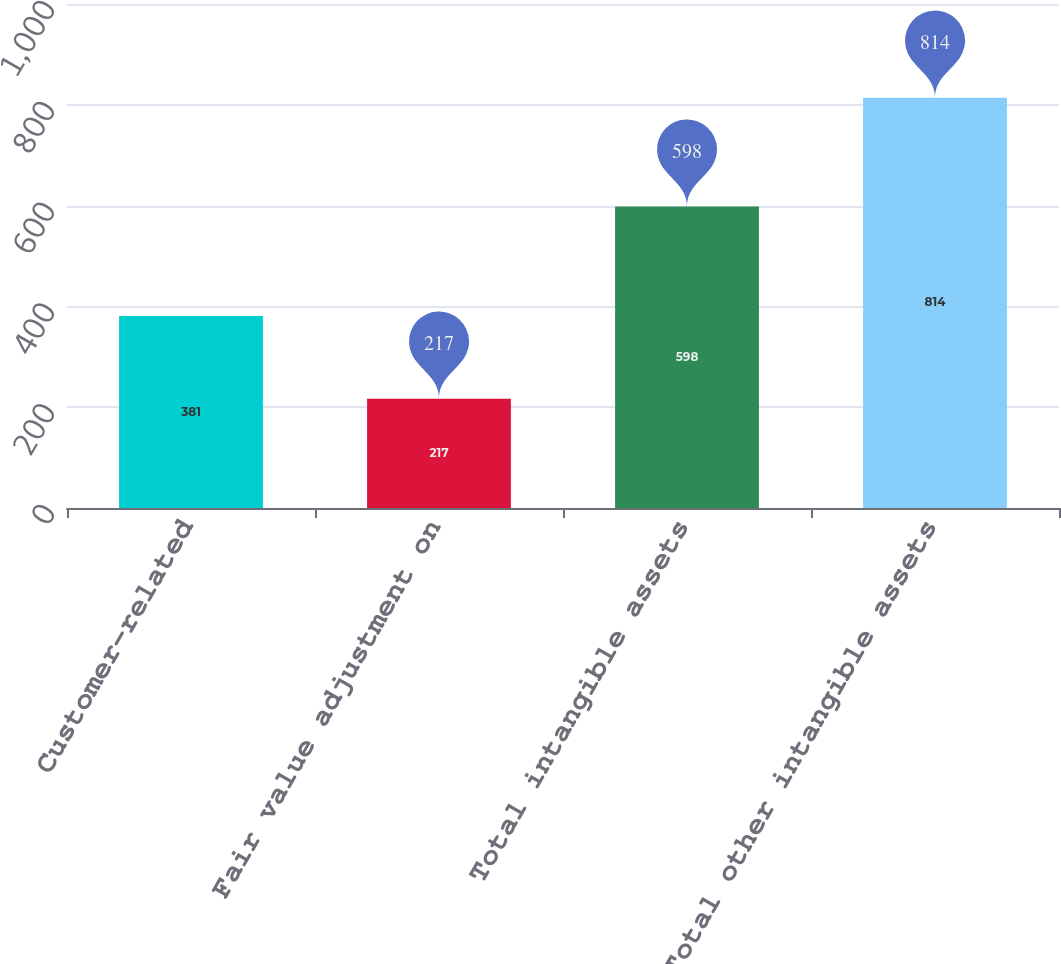Convert chart. <chart><loc_0><loc_0><loc_500><loc_500><bar_chart><fcel>Customer-related<fcel>Fair value adjustment on<fcel>Total intangible assets<fcel>Total other intangible assets<nl><fcel>381<fcel>217<fcel>598<fcel>814<nl></chart> 